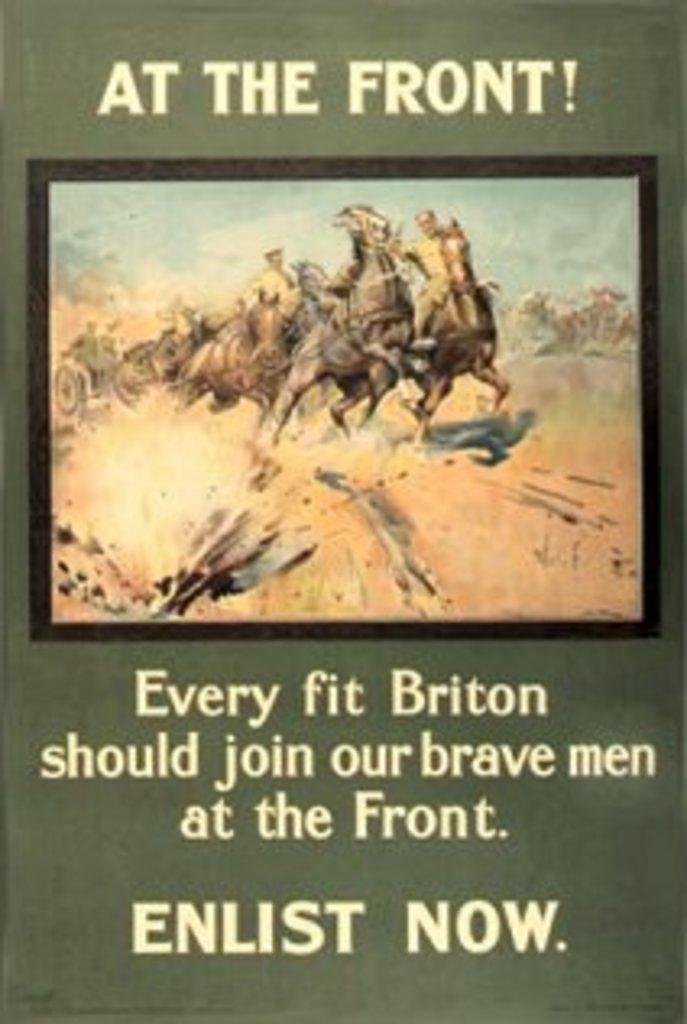What is the title at the top say?
Make the answer very short. At the front!. What should you do to join the front?
Offer a very short reply. Enlist now. 